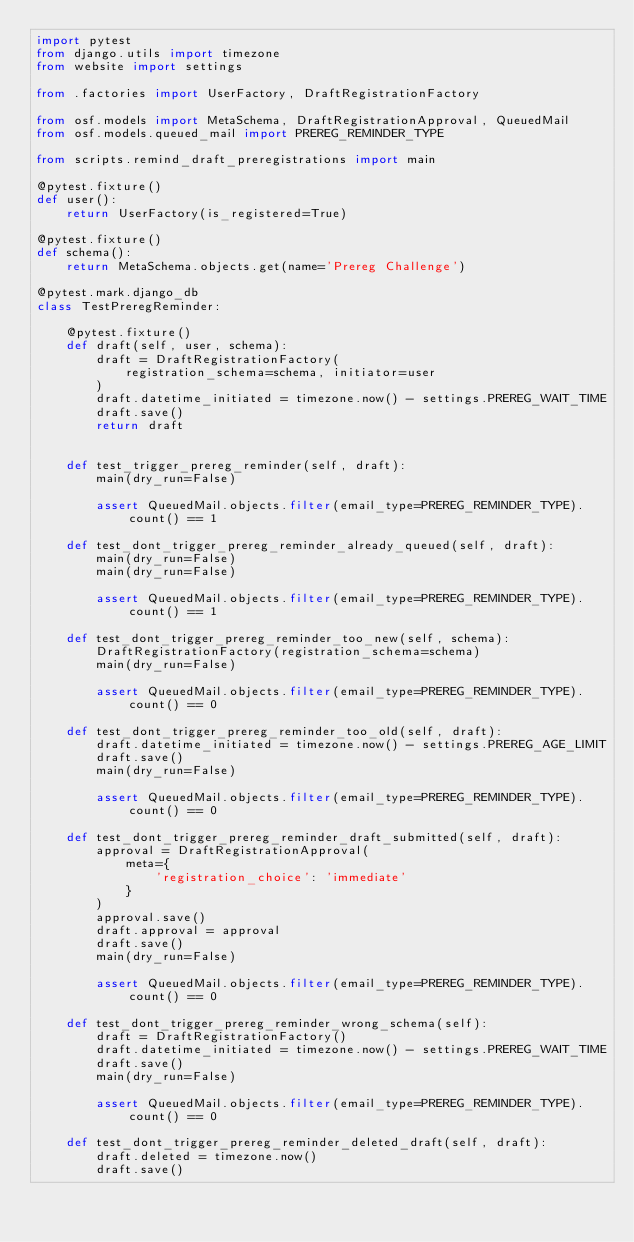Convert code to text. <code><loc_0><loc_0><loc_500><loc_500><_Python_>import pytest
from django.utils import timezone
from website import settings

from .factories import UserFactory, DraftRegistrationFactory

from osf.models import MetaSchema, DraftRegistrationApproval, QueuedMail
from osf.models.queued_mail import PREREG_REMINDER_TYPE

from scripts.remind_draft_preregistrations import main

@pytest.fixture()
def user():
    return UserFactory(is_registered=True)

@pytest.fixture()
def schema():
    return MetaSchema.objects.get(name='Prereg Challenge')

@pytest.mark.django_db
class TestPreregReminder:

    @pytest.fixture()
    def draft(self, user, schema):
        draft = DraftRegistrationFactory(
            registration_schema=schema, initiator=user
        )
        draft.datetime_initiated = timezone.now() - settings.PREREG_WAIT_TIME
        draft.save()
        return draft


    def test_trigger_prereg_reminder(self, draft):
        main(dry_run=False)

        assert QueuedMail.objects.filter(email_type=PREREG_REMINDER_TYPE).count() == 1

    def test_dont_trigger_prereg_reminder_already_queued(self, draft):
        main(dry_run=False)
        main(dry_run=False)

        assert QueuedMail.objects.filter(email_type=PREREG_REMINDER_TYPE).count() == 1

    def test_dont_trigger_prereg_reminder_too_new(self, schema):
        DraftRegistrationFactory(registration_schema=schema)
        main(dry_run=False)

        assert QueuedMail.objects.filter(email_type=PREREG_REMINDER_TYPE).count() == 0

    def test_dont_trigger_prereg_reminder_too_old(self, draft):
        draft.datetime_initiated = timezone.now() - settings.PREREG_AGE_LIMIT
        draft.save()
        main(dry_run=False)

        assert QueuedMail.objects.filter(email_type=PREREG_REMINDER_TYPE).count() == 0

    def test_dont_trigger_prereg_reminder_draft_submitted(self, draft):
        approval = DraftRegistrationApproval(
            meta={
                'registration_choice': 'immediate'
            }
        )
        approval.save()
        draft.approval = approval
        draft.save()
        main(dry_run=False)

        assert QueuedMail.objects.filter(email_type=PREREG_REMINDER_TYPE).count() == 0

    def test_dont_trigger_prereg_reminder_wrong_schema(self):
        draft = DraftRegistrationFactory()
        draft.datetime_initiated = timezone.now() - settings.PREREG_WAIT_TIME
        draft.save()
        main(dry_run=False)

        assert QueuedMail.objects.filter(email_type=PREREG_REMINDER_TYPE).count() == 0

    def test_dont_trigger_prereg_reminder_deleted_draft(self, draft):
        draft.deleted = timezone.now()
        draft.save()</code> 